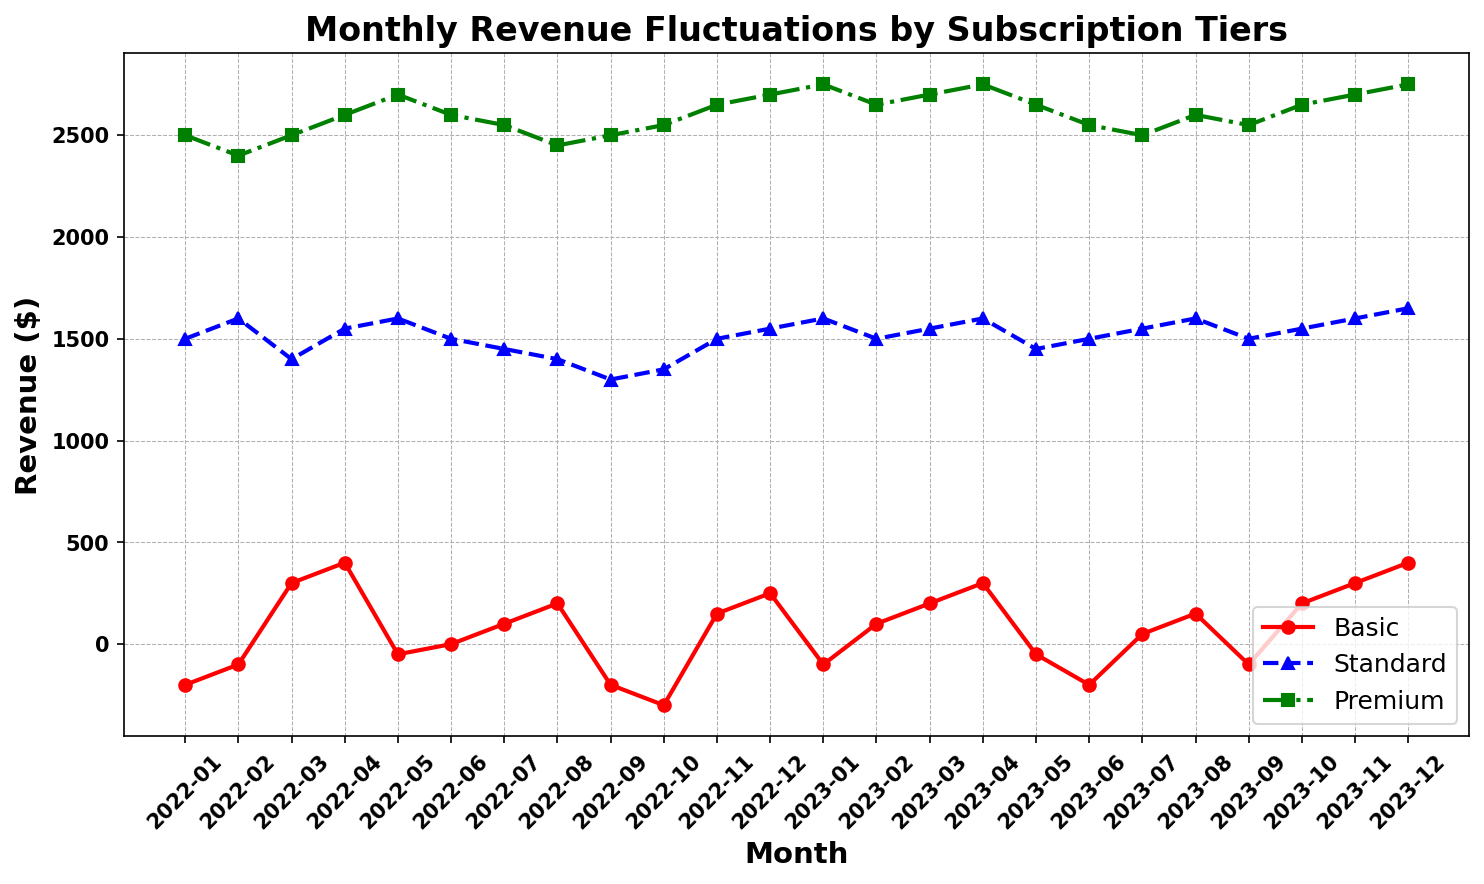What is the revenue trend of the Basic subscription tier throughout the year? Observe the red line representing the Basic subscription. It fluctuates significantly, often dipping into negative values, especially in January, February, September, October, and January of the next year. It shows sporadic positive spikes but remains volatile throughout.
Answer: Volatile with negative and positive fluctuations Which subscription tier had the highest revenue in December 2023? Refer to the end of the green, blue, and red lines in December 2023. The green line (Premium) consistently stays above the others, thus having the highest revenue.
Answer: Premium Between which months did the Premium subscription tier see the greatest increase in revenue in 2023? Focus on the green line representing the Premium tier between months. The largest jump appears from January 2023 to February 2023.
Answer: January to February 2023 What is the pattern of revenue changes for the Standard subscription tier from February to May 2023? Observe the blue line representing the Standard tier, from February to May 2023. The revenue shows a slight decrease from February (1600) to March (1550), further dips to April (1600), then drops slightly to May (1450).
Answer: Decrease, dip, drop How does the volatility of the Basic subscription compare to the Premium subscription over the entire timeframe? Compare the peaks and troughs of the red and green lines. The red line (Basic) exhibits more extreme fluctuations, swinging between negative and positive values, whereas the green line (Premium) shows relatively steady increases and decreases.
Answer: Basic is more volatile In which month did the Basic tier have its highest revenue, and what was the value? Look for the highest point on the red line. It occurs in December 2023, where the value is 400.
Answer: December 2023, 400 Calculate the average monthly revenue for the Standard tier in 2023. Identify monthly revenues for Standard in 2023: 1600, 1500, 1550, 1600, 1450, 1500, 1550, 1600, 1500, 1550, 1600, 1650. Sum: (1600 + 1500 + 1550 + 1600 + 1450 + 1500 + 1550 + 1600 + 1500 + 1550 + 1600 + 1650) = 18650. Average: 18650 / 12 = 1554.17
Answer: 1554.17 Which subscription tier showed the greatest overall growth from January 2022 to December 2023? Compare the starting and ending points for each tier. Basic (-200 to 400), Standard (1500 to 1650), and Premium (2500 to 2750). The Premium tier shows the overall largest positive change (250).
Answer: Premium During which month did all three subscription tiers experience an increase in comparison to the previous month? Check consecutive months for a simultaneous increase. February 2023: 
Basic (-100 to 100), Standard (1600 to 1500), Premium (2750 to 2650); March 2023: 
Basic (100 to 200), Standard (1500 to 1550), Premium (2650 to 2700). April 2023: 
Basic (300), Standard (1600), Premium (2750) – consistent increase in all tiers.
Answer: April 2023 